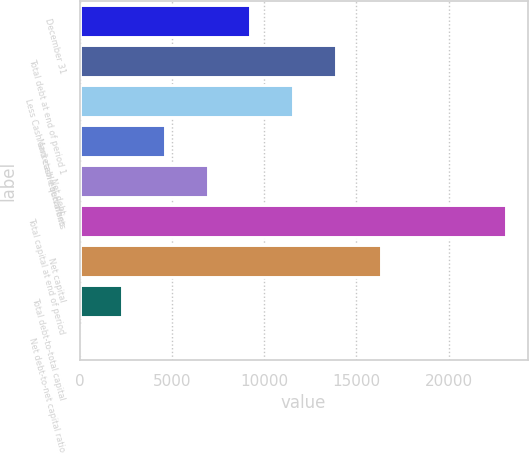<chart> <loc_0><loc_0><loc_500><loc_500><bar_chart><fcel>December 31<fcel>Total debt at end of period 1<fcel>Less Cash and cash equivalents<fcel>Marketable securities<fcel>Net debt<fcel>Total capital at end of period<fcel>Net capital<fcel>Total debt-to-total capital<fcel>Net debt-to-net capital ratio<nl><fcel>9246.7<fcel>13868.8<fcel>11557.8<fcel>4624.6<fcel>6935.65<fcel>23113<fcel>16345<fcel>2313.55<fcel>2.5<nl></chart> 